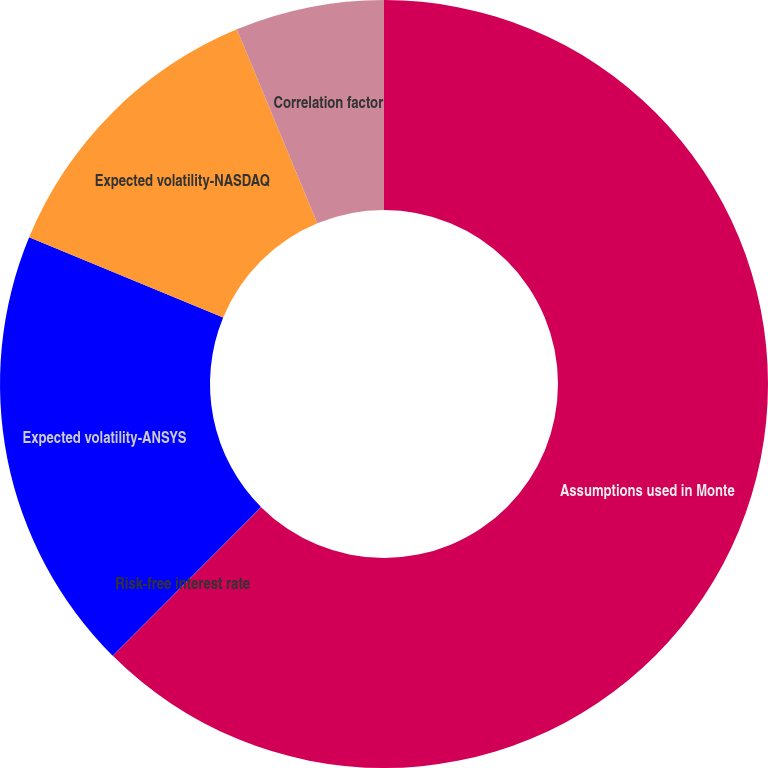Convert chart. <chart><loc_0><loc_0><loc_500><loc_500><pie_chart><fcel>Assumptions used in Monte<fcel>Risk-free interest rate<fcel>Expected volatility-ANSYS<fcel>Expected volatility-NASDAQ<fcel>Correlation factor<nl><fcel>62.48%<fcel>0.01%<fcel>18.75%<fcel>12.5%<fcel>6.26%<nl></chart> 